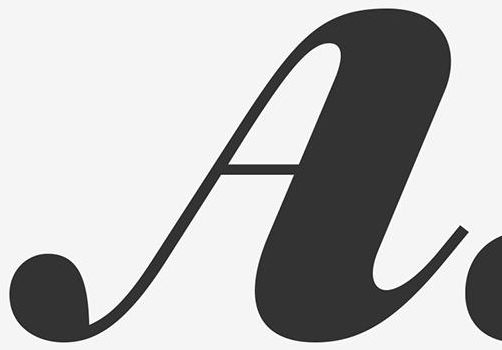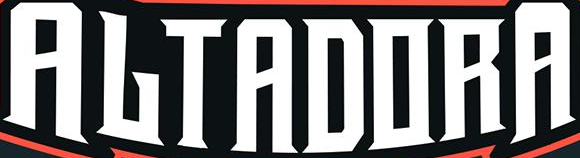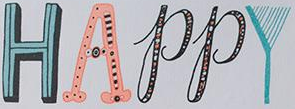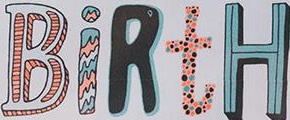What text appears in these images from left to right, separated by a semicolon? A; ALTADORA; HAPPY; BiRtH 